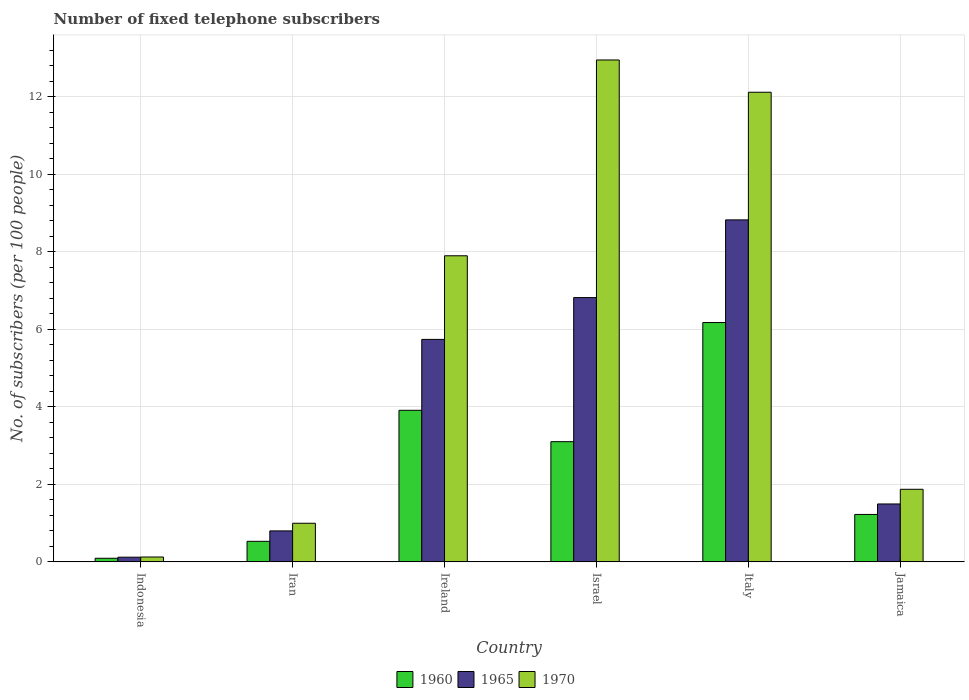How many different coloured bars are there?
Make the answer very short. 3. Are the number of bars on each tick of the X-axis equal?
Ensure brevity in your answer.  Yes. How many bars are there on the 2nd tick from the left?
Offer a very short reply. 3. What is the label of the 4th group of bars from the left?
Your answer should be compact. Israel. What is the number of fixed telephone subscribers in 1960 in Israel?
Your answer should be very brief. 3.1. Across all countries, what is the maximum number of fixed telephone subscribers in 1965?
Offer a very short reply. 8.82. Across all countries, what is the minimum number of fixed telephone subscribers in 1960?
Your response must be concise. 0.09. What is the total number of fixed telephone subscribers in 1960 in the graph?
Provide a short and direct response. 15.03. What is the difference between the number of fixed telephone subscribers in 1970 in Israel and that in Italy?
Offer a terse response. 0.83. What is the difference between the number of fixed telephone subscribers in 1965 in Iran and the number of fixed telephone subscribers in 1960 in Italy?
Your answer should be compact. -5.38. What is the average number of fixed telephone subscribers in 1965 per country?
Keep it short and to the point. 3.97. What is the difference between the number of fixed telephone subscribers of/in 1965 and number of fixed telephone subscribers of/in 1970 in Indonesia?
Provide a succinct answer. -0. In how many countries, is the number of fixed telephone subscribers in 1965 greater than 6.4?
Offer a very short reply. 2. What is the ratio of the number of fixed telephone subscribers in 1965 in Iran to that in Jamaica?
Make the answer very short. 0.53. Is the difference between the number of fixed telephone subscribers in 1965 in Indonesia and Ireland greater than the difference between the number of fixed telephone subscribers in 1970 in Indonesia and Ireland?
Provide a short and direct response. Yes. What is the difference between the highest and the second highest number of fixed telephone subscribers in 1960?
Provide a short and direct response. -0.81. What is the difference between the highest and the lowest number of fixed telephone subscribers in 1970?
Your response must be concise. 12.82. What does the 2nd bar from the left in Iran represents?
Provide a succinct answer. 1965. What does the 1st bar from the right in Jamaica represents?
Keep it short and to the point. 1970. How many bars are there?
Provide a short and direct response. 18. How many countries are there in the graph?
Your answer should be very brief. 6. Does the graph contain any zero values?
Your answer should be very brief. No. Where does the legend appear in the graph?
Provide a short and direct response. Bottom center. What is the title of the graph?
Your response must be concise. Number of fixed telephone subscribers. Does "1985" appear as one of the legend labels in the graph?
Provide a short and direct response. No. What is the label or title of the Y-axis?
Your answer should be compact. No. of subscribers (per 100 people). What is the No. of subscribers (per 100 people) in 1960 in Indonesia?
Make the answer very short. 0.09. What is the No. of subscribers (per 100 people) in 1965 in Indonesia?
Ensure brevity in your answer.  0.12. What is the No. of subscribers (per 100 people) in 1970 in Indonesia?
Your answer should be very brief. 0.13. What is the No. of subscribers (per 100 people) in 1960 in Iran?
Your answer should be very brief. 0.53. What is the No. of subscribers (per 100 people) in 1965 in Iran?
Offer a very short reply. 0.8. What is the No. of subscribers (per 100 people) of 1970 in Iran?
Your answer should be very brief. 1. What is the No. of subscribers (per 100 people) of 1960 in Ireland?
Make the answer very short. 3.91. What is the No. of subscribers (per 100 people) of 1965 in Ireland?
Offer a terse response. 5.74. What is the No. of subscribers (per 100 people) of 1970 in Ireland?
Keep it short and to the point. 7.9. What is the No. of subscribers (per 100 people) in 1960 in Israel?
Provide a short and direct response. 3.1. What is the No. of subscribers (per 100 people) in 1965 in Israel?
Offer a very short reply. 6.82. What is the No. of subscribers (per 100 people) of 1970 in Israel?
Your response must be concise. 12.95. What is the No. of subscribers (per 100 people) in 1960 in Italy?
Provide a short and direct response. 6.17. What is the No. of subscribers (per 100 people) of 1965 in Italy?
Your response must be concise. 8.82. What is the No. of subscribers (per 100 people) of 1970 in Italy?
Offer a very short reply. 12.12. What is the No. of subscribers (per 100 people) of 1960 in Jamaica?
Provide a succinct answer. 1.22. What is the No. of subscribers (per 100 people) in 1965 in Jamaica?
Keep it short and to the point. 1.49. What is the No. of subscribers (per 100 people) in 1970 in Jamaica?
Make the answer very short. 1.87. Across all countries, what is the maximum No. of subscribers (per 100 people) of 1960?
Your answer should be very brief. 6.17. Across all countries, what is the maximum No. of subscribers (per 100 people) in 1965?
Offer a very short reply. 8.82. Across all countries, what is the maximum No. of subscribers (per 100 people) of 1970?
Offer a terse response. 12.95. Across all countries, what is the minimum No. of subscribers (per 100 people) of 1960?
Keep it short and to the point. 0.09. Across all countries, what is the minimum No. of subscribers (per 100 people) in 1965?
Ensure brevity in your answer.  0.12. Across all countries, what is the minimum No. of subscribers (per 100 people) in 1970?
Keep it short and to the point. 0.13. What is the total No. of subscribers (per 100 people) in 1960 in the graph?
Provide a short and direct response. 15.03. What is the total No. of subscribers (per 100 people) in 1965 in the graph?
Your answer should be compact. 23.8. What is the total No. of subscribers (per 100 people) of 1970 in the graph?
Offer a terse response. 35.96. What is the difference between the No. of subscribers (per 100 people) in 1960 in Indonesia and that in Iran?
Keep it short and to the point. -0.44. What is the difference between the No. of subscribers (per 100 people) in 1965 in Indonesia and that in Iran?
Your answer should be very brief. -0.68. What is the difference between the No. of subscribers (per 100 people) of 1970 in Indonesia and that in Iran?
Offer a terse response. -0.87. What is the difference between the No. of subscribers (per 100 people) in 1960 in Indonesia and that in Ireland?
Make the answer very short. -3.82. What is the difference between the No. of subscribers (per 100 people) of 1965 in Indonesia and that in Ireland?
Provide a short and direct response. -5.62. What is the difference between the No. of subscribers (per 100 people) of 1970 in Indonesia and that in Ireland?
Ensure brevity in your answer.  -7.77. What is the difference between the No. of subscribers (per 100 people) in 1960 in Indonesia and that in Israel?
Offer a terse response. -3.01. What is the difference between the No. of subscribers (per 100 people) in 1965 in Indonesia and that in Israel?
Your response must be concise. -6.7. What is the difference between the No. of subscribers (per 100 people) of 1970 in Indonesia and that in Israel?
Offer a very short reply. -12.82. What is the difference between the No. of subscribers (per 100 people) of 1960 in Indonesia and that in Italy?
Provide a short and direct response. -6.08. What is the difference between the No. of subscribers (per 100 people) of 1965 in Indonesia and that in Italy?
Make the answer very short. -8.7. What is the difference between the No. of subscribers (per 100 people) of 1970 in Indonesia and that in Italy?
Offer a very short reply. -11.99. What is the difference between the No. of subscribers (per 100 people) in 1960 in Indonesia and that in Jamaica?
Your answer should be compact. -1.13. What is the difference between the No. of subscribers (per 100 people) in 1965 in Indonesia and that in Jamaica?
Keep it short and to the point. -1.37. What is the difference between the No. of subscribers (per 100 people) in 1970 in Indonesia and that in Jamaica?
Provide a short and direct response. -1.75. What is the difference between the No. of subscribers (per 100 people) of 1960 in Iran and that in Ireland?
Ensure brevity in your answer.  -3.38. What is the difference between the No. of subscribers (per 100 people) in 1965 in Iran and that in Ireland?
Offer a very short reply. -4.94. What is the difference between the No. of subscribers (per 100 people) of 1970 in Iran and that in Ireland?
Offer a very short reply. -6.9. What is the difference between the No. of subscribers (per 100 people) in 1960 in Iran and that in Israel?
Your answer should be very brief. -2.57. What is the difference between the No. of subscribers (per 100 people) in 1965 in Iran and that in Israel?
Offer a terse response. -6.02. What is the difference between the No. of subscribers (per 100 people) in 1970 in Iran and that in Israel?
Provide a succinct answer. -11.95. What is the difference between the No. of subscribers (per 100 people) in 1960 in Iran and that in Italy?
Your answer should be compact. -5.64. What is the difference between the No. of subscribers (per 100 people) of 1965 in Iran and that in Italy?
Make the answer very short. -8.02. What is the difference between the No. of subscribers (per 100 people) of 1970 in Iran and that in Italy?
Your answer should be very brief. -11.12. What is the difference between the No. of subscribers (per 100 people) in 1960 in Iran and that in Jamaica?
Your answer should be very brief. -0.69. What is the difference between the No. of subscribers (per 100 people) in 1965 in Iran and that in Jamaica?
Provide a succinct answer. -0.69. What is the difference between the No. of subscribers (per 100 people) in 1970 in Iran and that in Jamaica?
Offer a very short reply. -0.88. What is the difference between the No. of subscribers (per 100 people) in 1960 in Ireland and that in Israel?
Make the answer very short. 0.81. What is the difference between the No. of subscribers (per 100 people) in 1965 in Ireland and that in Israel?
Your answer should be compact. -1.08. What is the difference between the No. of subscribers (per 100 people) of 1970 in Ireland and that in Israel?
Provide a succinct answer. -5.05. What is the difference between the No. of subscribers (per 100 people) of 1960 in Ireland and that in Italy?
Provide a short and direct response. -2.26. What is the difference between the No. of subscribers (per 100 people) of 1965 in Ireland and that in Italy?
Your answer should be compact. -3.08. What is the difference between the No. of subscribers (per 100 people) of 1970 in Ireland and that in Italy?
Offer a terse response. -4.22. What is the difference between the No. of subscribers (per 100 people) of 1960 in Ireland and that in Jamaica?
Your answer should be compact. 2.69. What is the difference between the No. of subscribers (per 100 people) of 1965 in Ireland and that in Jamaica?
Your response must be concise. 4.25. What is the difference between the No. of subscribers (per 100 people) of 1970 in Ireland and that in Jamaica?
Keep it short and to the point. 6.02. What is the difference between the No. of subscribers (per 100 people) in 1960 in Israel and that in Italy?
Your answer should be very brief. -3.07. What is the difference between the No. of subscribers (per 100 people) in 1965 in Israel and that in Italy?
Ensure brevity in your answer.  -2. What is the difference between the No. of subscribers (per 100 people) in 1970 in Israel and that in Italy?
Your answer should be compact. 0.83. What is the difference between the No. of subscribers (per 100 people) of 1960 in Israel and that in Jamaica?
Your answer should be compact. 1.88. What is the difference between the No. of subscribers (per 100 people) in 1965 in Israel and that in Jamaica?
Keep it short and to the point. 5.32. What is the difference between the No. of subscribers (per 100 people) in 1970 in Israel and that in Jamaica?
Your answer should be compact. 11.08. What is the difference between the No. of subscribers (per 100 people) of 1960 in Italy and that in Jamaica?
Provide a short and direct response. 4.95. What is the difference between the No. of subscribers (per 100 people) of 1965 in Italy and that in Jamaica?
Your answer should be very brief. 7.33. What is the difference between the No. of subscribers (per 100 people) of 1970 in Italy and that in Jamaica?
Your answer should be very brief. 10.24. What is the difference between the No. of subscribers (per 100 people) in 1960 in Indonesia and the No. of subscribers (per 100 people) in 1965 in Iran?
Offer a terse response. -0.71. What is the difference between the No. of subscribers (per 100 people) in 1960 in Indonesia and the No. of subscribers (per 100 people) in 1970 in Iran?
Keep it short and to the point. -0.9. What is the difference between the No. of subscribers (per 100 people) of 1965 in Indonesia and the No. of subscribers (per 100 people) of 1970 in Iran?
Give a very brief answer. -0.88. What is the difference between the No. of subscribers (per 100 people) of 1960 in Indonesia and the No. of subscribers (per 100 people) of 1965 in Ireland?
Give a very brief answer. -5.65. What is the difference between the No. of subscribers (per 100 people) of 1960 in Indonesia and the No. of subscribers (per 100 people) of 1970 in Ireland?
Your answer should be very brief. -7.8. What is the difference between the No. of subscribers (per 100 people) in 1965 in Indonesia and the No. of subscribers (per 100 people) in 1970 in Ireland?
Provide a succinct answer. -7.78. What is the difference between the No. of subscribers (per 100 people) in 1960 in Indonesia and the No. of subscribers (per 100 people) in 1965 in Israel?
Offer a terse response. -6.73. What is the difference between the No. of subscribers (per 100 people) of 1960 in Indonesia and the No. of subscribers (per 100 people) of 1970 in Israel?
Give a very brief answer. -12.86. What is the difference between the No. of subscribers (per 100 people) in 1965 in Indonesia and the No. of subscribers (per 100 people) in 1970 in Israel?
Provide a short and direct response. -12.83. What is the difference between the No. of subscribers (per 100 people) in 1960 in Indonesia and the No. of subscribers (per 100 people) in 1965 in Italy?
Your answer should be compact. -8.73. What is the difference between the No. of subscribers (per 100 people) of 1960 in Indonesia and the No. of subscribers (per 100 people) of 1970 in Italy?
Keep it short and to the point. -12.02. What is the difference between the No. of subscribers (per 100 people) in 1965 in Indonesia and the No. of subscribers (per 100 people) in 1970 in Italy?
Offer a terse response. -12. What is the difference between the No. of subscribers (per 100 people) of 1960 in Indonesia and the No. of subscribers (per 100 people) of 1965 in Jamaica?
Offer a very short reply. -1.4. What is the difference between the No. of subscribers (per 100 people) in 1960 in Indonesia and the No. of subscribers (per 100 people) in 1970 in Jamaica?
Give a very brief answer. -1.78. What is the difference between the No. of subscribers (per 100 people) of 1965 in Indonesia and the No. of subscribers (per 100 people) of 1970 in Jamaica?
Your answer should be very brief. -1.75. What is the difference between the No. of subscribers (per 100 people) in 1960 in Iran and the No. of subscribers (per 100 people) in 1965 in Ireland?
Ensure brevity in your answer.  -5.21. What is the difference between the No. of subscribers (per 100 people) of 1960 in Iran and the No. of subscribers (per 100 people) of 1970 in Ireland?
Provide a succinct answer. -7.37. What is the difference between the No. of subscribers (per 100 people) of 1965 in Iran and the No. of subscribers (per 100 people) of 1970 in Ireland?
Offer a terse response. -7.1. What is the difference between the No. of subscribers (per 100 people) of 1960 in Iran and the No. of subscribers (per 100 people) of 1965 in Israel?
Offer a very short reply. -6.29. What is the difference between the No. of subscribers (per 100 people) in 1960 in Iran and the No. of subscribers (per 100 people) in 1970 in Israel?
Provide a short and direct response. -12.42. What is the difference between the No. of subscribers (per 100 people) in 1965 in Iran and the No. of subscribers (per 100 people) in 1970 in Israel?
Make the answer very short. -12.15. What is the difference between the No. of subscribers (per 100 people) of 1960 in Iran and the No. of subscribers (per 100 people) of 1965 in Italy?
Your answer should be very brief. -8.29. What is the difference between the No. of subscribers (per 100 people) in 1960 in Iran and the No. of subscribers (per 100 people) in 1970 in Italy?
Your answer should be very brief. -11.59. What is the difference between the No. of subscribers (per 100 people) of 1965 in Iran and the No. of subscribers (per 100 people) of 1970 in Italy?
Your answer should be very brief. -11.32. What is the difference between the No. of subscribers (per 100 people) in 1960 in Iran and the No. of subscribers (per 100 people) in 1965 in Jamaica?
Keep it short and to the point. -0.96. What is the difference between the No. of subscribers (per 100 people) of 1960 in Iran and the No. of subscribers (per 100 people) of 1970 in Jamaica?
Your response must be concise. -1.34. What is the difference between the No. of subscribers (per 100 people) of 1965 in Iran and the No. of subscribers (per 100 people) of 1970 in Jamaica?
Your answer should be compact. -1.07. What is the difference between the No. of subscribers (per 100 people) of 1960 in Ireland and the No. of subscribers (per 100 people) of 1965 in Israel?
Keep it short and to the point. -2.91. What is the difference between the No. of subscribers (per 100 people) of 1960 in Ireland and the No. of subscribers (per 100 people) of 1970 in Israel?
Provide a short and direct response. -9.04. What is the difference between the No. of subscribers (per 100 people) of 1965 in Ireland and the No. of subscribers (per 100 people) of 1970 in Israel?
Your response must be concise. -7.21. What is the difference between the No. of subscribers (per 100 people) in 1960 in Ireland and the No. of subscribers (per 100 people) in 1965 in Italy?
Give a very brief answer. -4.91. What is the difference between the No. of subscribers (per 100 people) of 1960 in Ireland and the No. of subscribers (per 100 people) of 1970 in Italy?
Make the answer very short. -8.21. What is the difference between the No. of subscribers (per 100 people) of 1965 in Ireland and the No. of subscribers (per 100 people) of 1970 in Italy?
Provide a short and direct response. -6.38. What is the difference between the No. of subscribers (per 100 people) of 1960 in Ireland and the No. of subscribers (per 100 people) of 1965 in Jamaica?
Your answer should be very brief. 2.42. What is the difference between the No. of subscribers (per 100 people) of 1960 in Ireland and the No. of subscribers (per 100 people) of 1970 in Jamaica?
Keep it short and to the point. 2.04. What is the difference between the No. of subscribers (per 100 people) in 1965 in Ireland and the No. of subscribers (per 100 people) in 1970 in Jamaica?
Keep it short and to the point. 3.87. What is the difference between the No. of subscribers (per 100 people) of 1960 in Israel and the No. of subscribers (per 100 people) of 1965 in Italy?
Provide a short and direct response. -5.72. What is the difference between the No. of subscribers (per 100 people) in 1960 in Israel and the No. of subscribers (per 100 people) in 1970 in Italy?
Provide a short and direct response. -9.02. What is the difference between the No. of subscribers (per 100 people) of 1965 in Israel and the No. of subscribers (per 100 people) of 1970 in Italy?
Your answer should be compact. -5.3. What is the difference between the No. of subscribers (per 100 people) in 1960 in Israel and the No. of subscribers (per 100 people) in 1965 in Jamaica?
Ensure brevity in your answer.  1.61. What is the difference between the No. of subscribers (per 100 people) of 1960 in Israel and the No. of subscribers (per 100 people) of 1970 in Jamaica?
Your answer should be compact. 1.23. What is the difference between the No. of subscribers (per 100 people) of 1965 in Israel and the No. of subscribers (per 100 people) of 1970 in Jamaica?
Give a very brief answer. 4.95. What is the difference between the No. of subscribers (per 100 people) in 1960 in Italy and the No. of subscribers (per 100 people) in 1965 in Jamaica?
Provide a short and direct response. 4.68. What is the difference between the No. of subscribers (per 100 people) in 1960 in Italy and the No. of subscribers (per 100 people) in 1970 in Jamaica?
Give a very brief answer. 4.3. What is the difference between the No. of subscribers (per 100 people) of 1965 in Italy and the No. of subscribers (per 100 people) of 1970 in Jamaica?
Keep it short and to the point. 6.95. What is the average No. of subscribers (per 100 people) of 1960 per country?
Your response must be concise. 2.51. What is the average No. of subscribers (per 100 people) in 1965 per country?
Provide a short and direct response. 3.97. What is the average No. of subscribers (per 100 people) of 1970 per country?
Your response must be concise. 5.99. What is the difference between the No. of subscribers (per 100 people) of 1960 and No. of subscribers (per 100 people) of 1965 in Indonesia?
Your answer should be compact. -0.03. What is the difference between the No. of subscribers (per 100 people) in 1960 and No. of subscribers (per 100 people) in 1970 in Indonesia?
Provide a short and direct response. -0.03. What is the difference between the No. of subscribers (per 100 people) of 1965 and No. of subscribers (per 100 people) of 1970 in Indonesia?
Your answer should be compact. -0. What is the difference between the No. of subscribers (per 100 people) of 1960 and No. of subscribers (per 100 people) of 1965 in Iran?
Your response must be concise. -0.27. What is the difference between the No. of subscribers (per 100 people) in 1960 and No. of subscribers (per 100 people) in 1970 in Iran?
Ensure brevity in your answer.  -0.47. What is the difference between the No. of subscribers (per 100 people) in 1965 and No. of subscribers (per 100 people) in 1970 in Iran?
Make the answer very short. -0.2. What is the difference between the No. of subscribers (per 100 people) in 1960 and No. of subscribers (per 100 people) in 1965 in Ireland?
Your answer should be very brief. -1.83. What is the difference between the No. of subscribers (per 100 people) in 1960 and No. of subscribers (per 100 people) in 1970 in Ireland?
Offer a very short reply. -3.99. What is the difference between the No. of subscribers (per 100 people) in 1965 and No. of subscribers (per 100 people) in 1970 in Ireland?
Offer a very short reply. -2.16. What is the difference between the No. of subscribers (per 100 people) of 1960 and No. of subscribers (per 100 people) of 1965 in Israel?
Ensure brevity in your answer.  -3.72. What is the difference between the No. of subscribers (per 100 people) in 1960 and No. of subscribers (per 100 people) in 1970 in Israel?
Your response must be concise. -9.85. What is the difference between the No. of subscribers (per 100 people) in 1965 and No. of subscribers (per 100 people) in 1970 in Israel?
Provide a succinct answer. -6.13. What is the difference between the No. of subscribers (per 100 people) of 1960 and No. of subscribers (per 100 people) of 1965 in Italy?
Offer a terse response. -2.65. What is the difference between the No. of subscribers (per 100 people) of 1960 and No. of subscribers (per 100 people) of 1970 in Italy?
Offer a very short reply. -5.94. What is the difference between the No. of subscribers (per 100 people) of 1965 and No. of subscribers (per 100 people) of 1970 in Italy?
Ensure brevity in your answer.  -3.29. What is the difference between the No. of subscribers (per 100 people) of 1960 and No. of subscribers (per 100 people) of 1965 in Jamaica?
Make the answer very short. -0.27. What is the difference between the No. of subscribers (per 100 people) in 1960 and No. of subscribers (per 100 people) in 1970 in Jamaica?
Your response must be concise. -0.65. What is the difference between the No. of subscribers (per 100 people) in 1965 and No. of subscribers (per 100 people) in 1970 in Jamaica?
Offer a very short reply. -0.38. What is the ratio of the No. of subscribers (per 100 people) of 1960 in Indonesia to that in Iran?
Offer a terse response. 0.18. What is the ratio of the No. of subscribers (per 100 people) of 1965 in Indonesia to that in Iran?
Your answer should be compact. 0.15. What is the ratio of the No. of subscribers (per 100 people) in 1970 in Indonesia to that in Iran?
Ensure brevity in your answer.  0.13. What is the ratio of the No. of subscribers (per 100 people) of 1960 in Indonesia to that in Ireland?
Your answer should be compact. 0.02. What is the ratio of the No. of subscribers (per 100 people) of 1965 in Indonesia to that in Ireland?
Your answer should be very brief. 0.02. What is the ratio of the No. of subscribers (per 100 people) in 1970 in Indonesia to that in Ireland?
Your answer should be very brief. 0.02. What is the ratio of the No. of subscribers (per 100 people) of 1960 in Indonesia to that in Israel?
Provide a short and direct response. 0.03. What is the ratio of the No. of subscribers (per 100 people) in 1965 in Indonesia to that in Israel?
Make the answer very short. 0.02. What is the ratio of the No. of subscribers (per 100 people) of 1970 in Indonesia to that in Israel?
Make the answer very short. 0.01. What is the ratio of the No. of subscribers (per 100 people) of 1960 in Indonesia to that in Italy?
Keep it short and to the point. 0.02. What is the ratio of the No. of subscribers (per 100 people) in 1965 in Indonesia to that in Italy?
Ensure brevity in your answer.  0.01. What is the ratio of the No. of subscribers (per 100 people) in 1970 in Indonesia to that in Italy?
Make the answer very short. 0.01. What is the ratio of the No. of subscribers (per 100 people) of 1960 in Indonesia to that in Jamaica?
Make the answer very short. 0.08. What is the ratio of the No. of subscribers (per 100 people) of 1965 in Indonesia to that in Jamaica?
Ensure brevity in your answer.  0.08. What is the ratio of the No. of subscribers (per 100 people) in 1970 in Indonesia to that in Jamaica?
Make the answer very short. 0.07. What is the ratio of the No. of subscribers (per 100 people) in 1960 in Iran to that in Ireland?
Your answer should be very brief. 0.14. What is the ratio of the No. of subscribers (per 100 people) in 1965 in Iran to that in Ireland?
Offer a terse response. 0.14. What is the ratio of the No. of subscribers (per 100 people) of 1970 in Iran to that in Ireland?
Ensure brevity in your answer.  0.13. What is the ratio of the No. of subscribers (per 100 people) in 1960 in Iran to that in Israel?
Provide a short and direct response. 0.17. What is the ratio of the No. of subscribers (per 100 people) of 1965 in Iran to that in Israel?
Offer a terse response. 0.12. What is the ratio of the No. of subscribers (per 100 people) of 1970 in Iran to that in Israel?
Give a very brief answer. 0.08. What is the ratio of the No. of subscribers (per 100 people) in 1960 in Iran to that in Italy?
Make the answer very short. 0.09. What is the ratio of the No. of subscribers (per 100 people) in 1965 in Iran to that in Italy?
Provide a succinct answer. 0.09. What is the ratio of the No. of subscribers (per 100 people) of 1970 in Iran to that in Italy?
Your response must be concise. 0.08. What is the ratio of the No. of subscribers (per 100 people) of 1960 in Iran to that in Jamaica?
Ensure brevity in your answer.  0.43. What is the ratio of the No. of subscribers (per 100 people) of 1965 in Iran to that in Jamaica?
Keep it short and to the point. 0.53. What is the ratio of the No. of subscribers (per 100 people) of 1970 in Iran to that in Jamaica?
Keep it short and to the point. 0.53. What is the ratio of the No. of subscribers (per 100 people) of 1960 in Ireland to that in Israel?
Provide a short and direct response. 1.26. What is the ratio of the No. of subscribers (per 100 people) in 1965 in Ireland to that in Israel?
Offer a terse response. 0.84. What is the ratio of the No. of subscribers (per 100 people) in 1970 in Ireland to that in Israel?
Your answer should be very brief. 0.61. What is the ratio of the No. of subscribers (per 100 people) of 1960 in Ireland to that in Italy?
Offer a terse response. 0.63. What is the ratio of the No. of subscribers (per 100 people) of 1965 in Ireland to that in Italy?
Make the answer very short. 0.65. What is the ratio of the No. of subscribers (per 100 people) of 1970 in Ireland to that in Italy?
Keep it short and to the point. 0.65. What is the ratio of the No. of subscribers (per 100 people) in 1960 in Ireland to that in Jamaica?
Ensure brevity in your answer.  3.2. What is the ratio of the No. of subscribers (per 100 people) of 1965 in Ireland to that in Jamaica?
Offer a very short reply. 3.84. What is the ratio of the No. of subscribers (per 100 people) of 1970 in Ireland to that in Jamaica?
Ensure brevity in your answer.  4.22. What is the ratio of the No. of subscribers (per 100 people) of 1960 in Israel to that in Italy?
Offer a very short reply. 0.5. What is the ratio of the No. of subscribers (per 100 people) in 1965 in Israel to that in Italy?
Ensure brevity in your answer.  0.77. What is the ratio of the No. of subscribers (per 100 people) in 1970 in Israel to that in Italy?
Your answer should be very brief. 1.07. What is the ratio of the No. of subscribers (per 100 people) of 1960 in Israel to that in Jamaica?
Provide a succinct answer. 2.53. What is the ratio of the No. of subscribers (per 100 people) of 1965 in Israel to that in Jamaica?
Provide a short and direct response. 4.56. What is the ratio of the No. of subscribers (per 100 people) in 1970 in Israel to that in Jamaica?
Ensure brevity in your answer.  6.91. What is the ratio of the No. of subscribers (per 100 people) of 1960 in Italy to that in Jamaica?
Your answer should be very brief. 5.05. What is the ratio of the No. of subscribers (per 100 people) in 1965 in Italy to that in Jamaica?
Keep it short and to the point. 5.91. What is the ratio of the No. of subscribers (per 100 people) of 1970 in Italy to that in Jamaica?
Make the answer very short. 6.47. What is the difference between the highest and the second highest No. of subscribers (per 100 people) of 1960?
Ensure brevity in your answer.  2.26. What is the difference between the highest and the second highest No. of subscribers (per 100 people) in 1965?
Make the answer very short. 2. What is the difference between the highest and the second highest No. of subscribers (per 100 people) in 1970?
Give a very brief answer. 0.83. What is the difference between the highest and the lowest No. of subscribers (per 100 people) in 1960?
Ensure brevity in your answer.  6.08. What is the difference between the highest and the lowest No. of subscribers (per 100 people) of 1965?
Ensure brevity in your answer.  8.7. What is the difference between the highest and the lowest No. of subscribers (per 100 people) of 1970?
Ensure brevity in your answer.  12.82. 